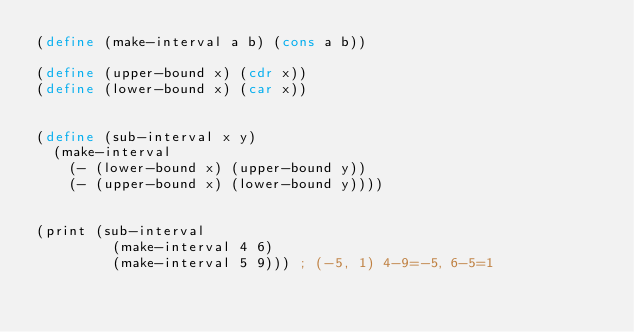Convert code to text. <code><loc_0><loc_0><loc_500><loc_500><_Scheme_>(define (make-interval a b) (cons a b))

(define (upper-bound x) (cdr x))
(define (lower-bound x) (car x))


(define (sub-interval x y)
  (make-interval
    (- (lower-bound x) (upper-bound y))
    (- (upper-bound x) (lower-bound y))))


(print (sub-interval
         (make-interval 4 6)
         (make-interval 5 9))) ; (-5, 1) 4-9=-5, 6-5=1
</code> 